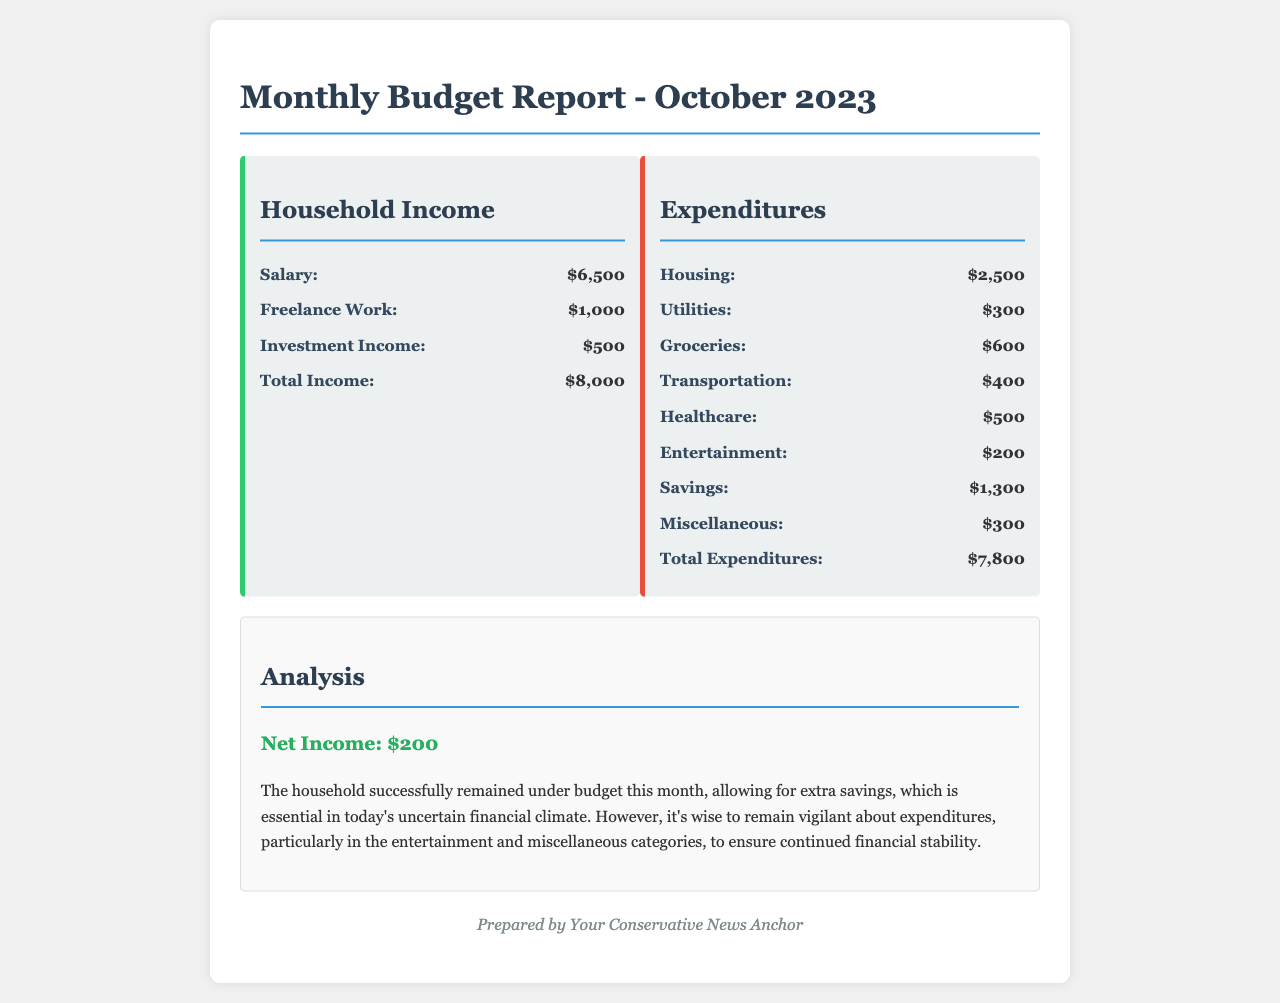What is the total income? The total income is the sum of all income sources listed in the document, which is $6500 + $1000 + $500 = $8000.
Answer: $8000 What is the expenditure on housing? The expenditure on housing is clearly mentioned in the document as $2500.
Answer: $2500 What is the net income? The net income is calculated as total income minus total expenditures, which is $8000 - $7800 = $200.
Answer: $200 What category has the highest expenditure? The highest expenditure category is housing, which amounts to $2500.
Answer: Housing What is the total expenditure? The total expenditure is the cumulative amount of all expenses listed in the document, which sums up to $7800.
Answer: $7800 How much was spent on entertainment? The document specifies that $200 was spent on entertainment.
Answer: $200 What is the savings amount? The amount saved by the household is detailed in the document as $1300.
Answer: $1300 Which category had the least expenditure? The category with the least expenditure is entertainment, which is $200.
Answer: Entertainment What is emphasized in the analysis section? The analysis section emphasizes remaining vigilant about expenditures, especially in the entertainment and miscellaneous categories.
Answer: Vigilance about expenditures 